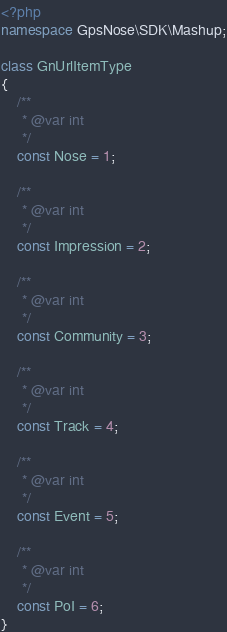<code> <loc_0><loc_0><loc_500><loc_500><_PHP_><?php
namespace GpsNose\SDK\Mashup;

class GnUrlItemType
{
    /**
     * @var int
     */
    const Nose = 1;

    /**
     * @var int
     */
    const Impression = 2;

    /**
     * @var int
     */
    const Community = 3;

    /**
     * @var int
     */
    const Track = 4;

    /**
     * @var int
     */
    const Event = 5;

    /**
     * @var int
     */
    const PoI = 6;
}
</code> 